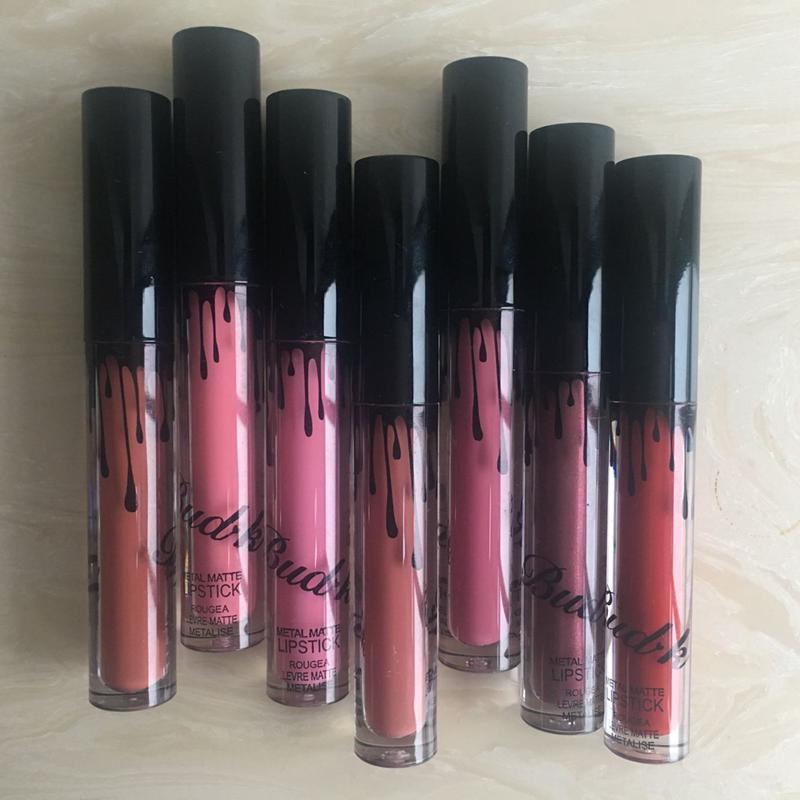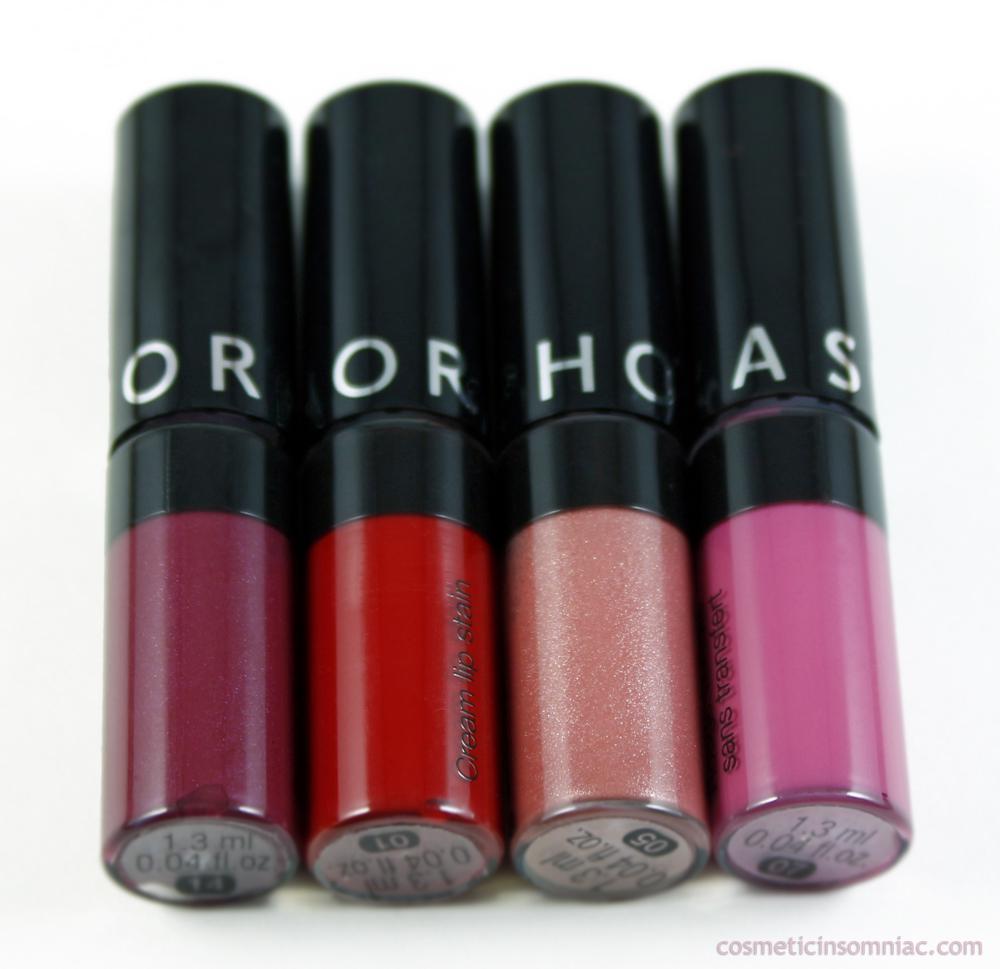The first image is the image on the left, the second image is the image on the right. Considering the images on both sides, is "One image shows two rows of lipsticks, with a rectangular box in front of them." valid? Answer yes or no. No. The first image is the image on the left, the second image is the image on the right. Assess this claim about the two images: "There is one box in the image on the left.". Correct or not? Answer yes or no. No. 